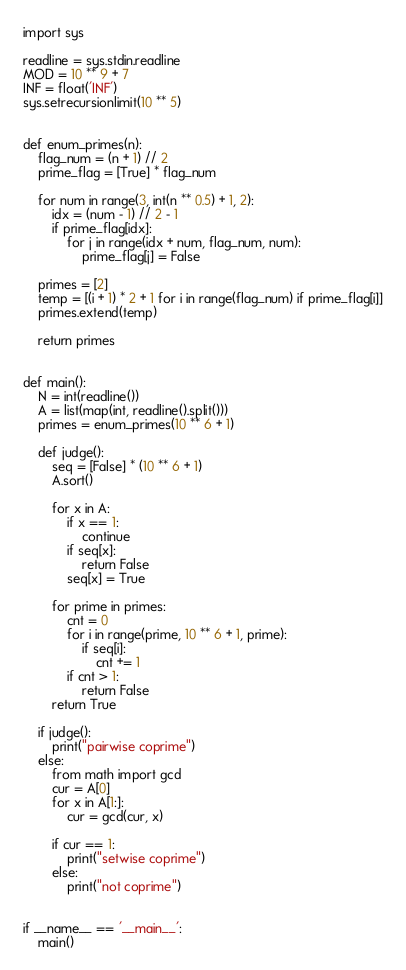Convert code to text. <code><loc_0><loc_0><loc_500><loc_500><_Python_>import sys

readline = sys.stdin.readline
MOD = 10 ** 9 + 7
INF = float('INF')
sys.setrecursionlimit(10 ** 5)


def enum_primes(n):
    flag_num = (n + 1) // 2
    prime_flag = [True] * flag_num

    for num in range(3, int(n ** 0.5) + 1, 2):
        idx = (num - 1) // 2 - 1
        if prime_flag[idx]:
            for j in range(idx + num, flag_num, num):
                prime_flag[j] = False

    primes = [2]
    temp = [(i + 1) * 2 + 1 for i in range(flag_num) if prime_flag[i]]
    primes.extend(temp)

    return primes


def main():
    N = int(readline())
    A = list(map(int, readline().split()))
    primes = enum_primes(10 ** 6 + 1)

    def judge():
        seq = [False] * (10 ** 6 + 1)
        A.sort()

        for x in A:
            if x == 1:
                continue
            if seq[x]:
                return False
            seq[x] = True

        for prime in primes:
            cnt = 0
            for i in range(prime, 10 ** 6 + 1, prime):
                if seq[i]:
                    cnt += 1
            if cnt > 1:
                return False
        return True

    if judge():
        print("pairwise coprime")
    else:
        from math import gcd
        cur = A[0]
        for x in A[1:]:
            cur = gcd(cur, x)

        if cur == 1:
            print("setwise coprime")
        else:
            print("not coprime")


if __name__ == '__main__':
    main()
</code> 